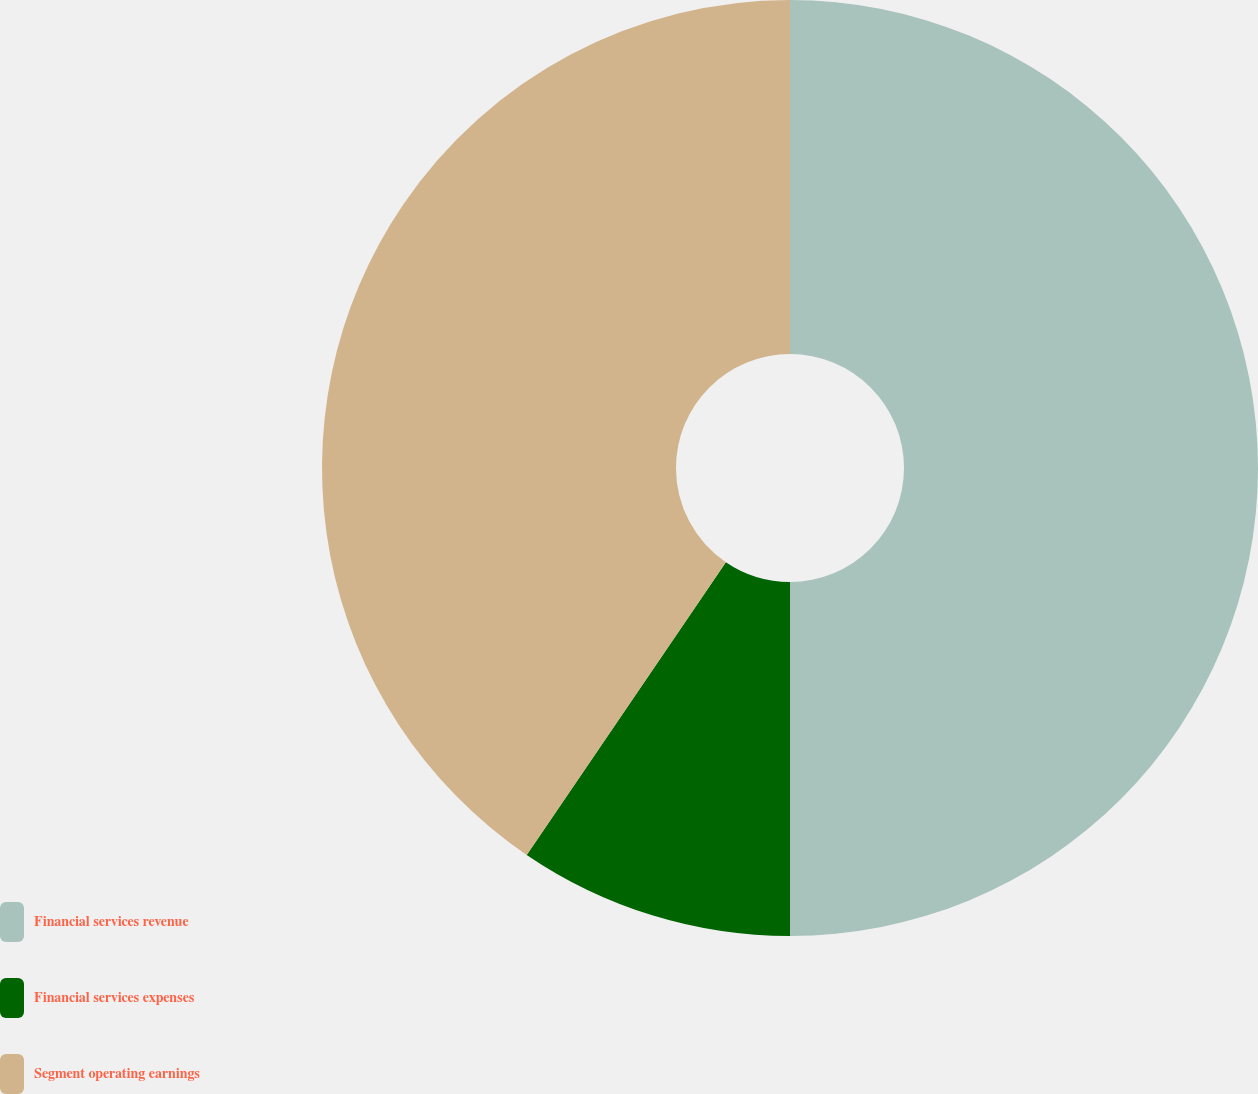Convert chart to OTSL. <chart><loc_0><loc_0><loc_500><loc_500><pie_chart><fcel>Financial services revenue<fcel>Financial services expenses<fcel>Segment operating earnings<nl><fcel>50.0%<fcel>9.51%<fcel>40.49%<nl></chart> 